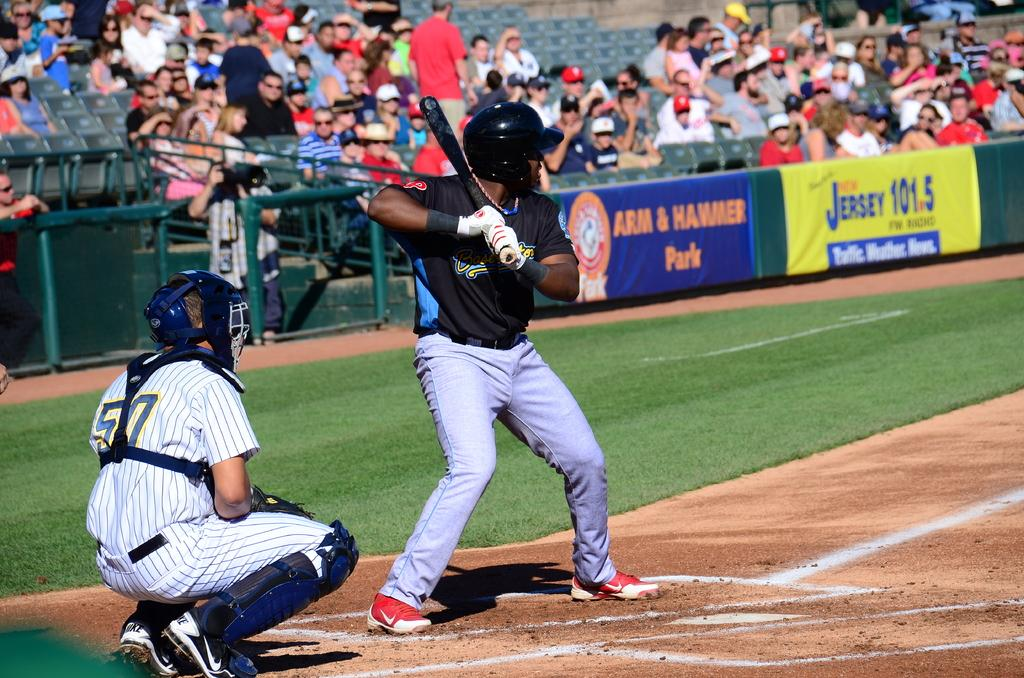Provide a one-sentence caption for the provided image. A baseball player up at bat at Arm & Hammer Park in Jersey. 